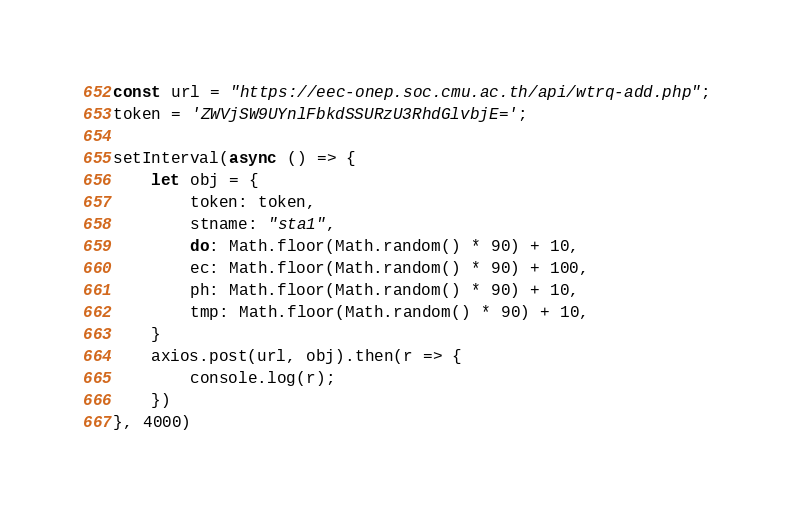Convert code to text. <code><loc_0><loc_0><loc_500><loc_500><_JavaScript_>const url = "https://eec-onep.soc.cmu.ac.th/api/wtrq-add.php";
token = 'ZWVjSW9UYnlFbkdSSURzU3RhdGlvbjE=';

setInterval(async () => {
    let obj = {
        token: token,
        stname: "sta1",
        do: Math.floor(Math.random() * 90) + 10,
        ec: Math.floor(Math.random() * 90) + 100,
        ph: Math.floor(Math.random() * 90) + 10,
        tmp: Math.floor(Math.random() * 90) + 10,
    }
    axios.post(url, obj).then(r => {
        console.log(r);
    })
}, 4000)
</code> 